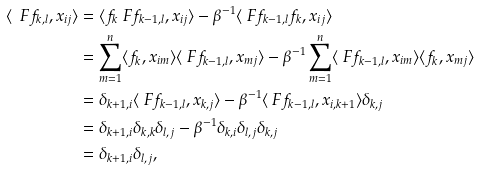<formula> <loc_0><loc_0><loc_500><loc_500>\langle \ F f _ { k , l } , x _ { i j } \rangle & = \langle f _ { k } \ F f _ { k - 1 , l } , x _ { i j } \rangle - \beta ^ { - 1 } \langle \ F f _ { k - 1 , l } f _ { k } , x _ { i j } \rangle \\ & = \sum _ { m = 1 } ^ { n } \langle f _ { k } , x _ { i m } \rangle \langle \ F f _ { k - 1 , l } , x _ { m j } \rangle - \beta ^ { - 1 } \sum _ { m = 1 } ^ { n } \langle \ F f _ { k - 1 , l } , x _ { i m } \rangle \langle f _ { k } , x _ { m j } \rangle \\ & = \delta _ { k + 1 , i } \langle \ F f _ { k - 1 , l } , x _ { k , j } \rangle - \beta ^ { - 1 } \langle \ F f _ { k - 1 , l } , x _ { i , k + 1 } \rangle \delta _ { k , j } \\ & = \delta _ { k + 1 , i } \delta _ { k , k } \delta _ { l , j } - \beta ^ { - 1 } \delta _ { k , i } \delta _ { l , j } \delta _ { k , j } \\ & = \delta _ { k + 1 , i } \delta _ { l , j } ,</formula> 